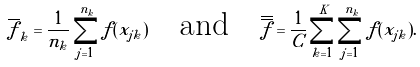Convert formula to latex. <formula><loc_0><loc_0><loc_500><loc_500>\overline { f } _ { k } = \frac { 1 } { n _ { k } } \sum _ { j = 1 } ^ { n _ { k } } f ( x _ { j k } ) \quad \text {and} \quad \overline { \overline { f } } = \frac { 1 } { C } \sum _ { k = 1 } ^ { K } \sum _ { j = 1 } ^ { n _ { k } } f ( x _ { j k } ) .</formula> 